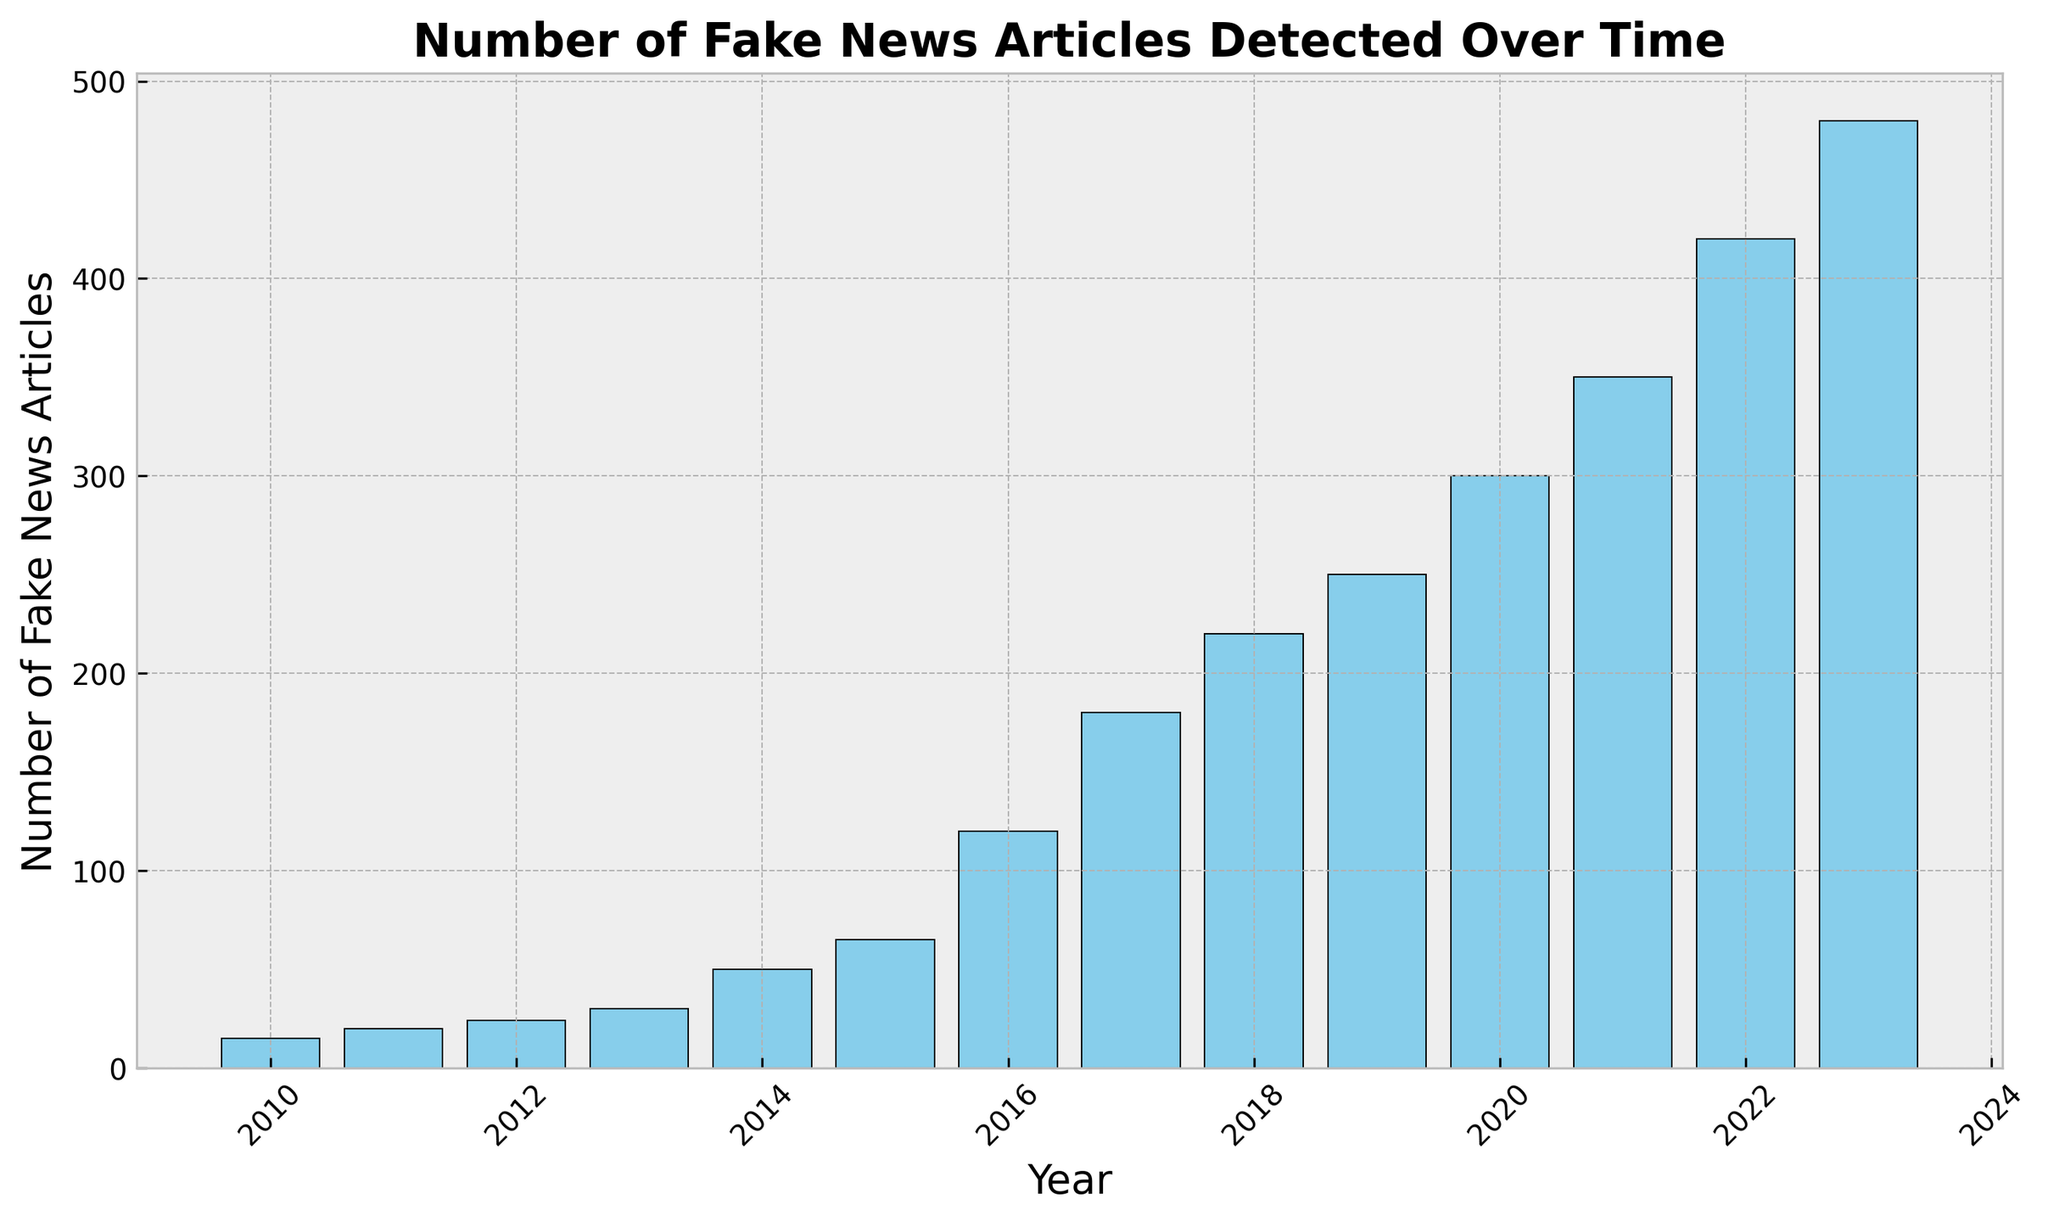What is the total number of fake news articles detected from 2010 to 2023? To find the total, sum all the values from the "NumberOfFakeNewsArticles" column: 15 + 20 + 24 + 30 + 50 + 65 + 120 + 180 + 220 + 250 + 300 + 350 + 420 + 480 = 2524
Answer: 2524 Which year saw the highest number of fake news articles detected? Simply find the tallest bar in the histogram. The year 2023 has the highest bar, representing the highest number of fake news articles at 480.
Answer: 2023 What is the increase in the number of fake news articles detected from 2013 to 2016? Subtract the number of fake news articles in 2013 from the number in 2016: 120 - 30 = 90
Answer: 90 How many years saw more than 200 fake news articles detected? Identify the bars with heights greater than 200. The years are 2018, 2019, 2020, 2021, 2022, and 2023. This totals to 6 years.
Answer: 6 What is the average number of fake news articles detected per year from 2010 to 2023? First, find the total number of fake news articles: 2524. Then divide by the number of years (14): 2524 / 14 ≈ 180.29
Answer: 180.29 By how much did the number of fake news articles increase from 2020 to 2021? Subtract the 2020 value from the 2021 value: 350 - 300 = 50
Answer: 50 Which year experienced the smallest increase in the number of fake news articles compared to the previous year? Calculate the yearly increases: (2011-2010) 5, (2012-2011) 4, (2013-2012) 6, (2014-2013) 20, (2015-2014) 15, (2016-2015) 55, (2017-2016) 60, (2018-2017) 40, (2019-2018) 30, (2020-2019) 50, (2021-2020) 50, (2022-2021) 70, (2023-2022) 60. The smallest increase is from 2012 to 2011 with an increase of 4 articles.
Answer: 2012 What is the median number of fake news articles detected from 2010 to 2023? First, list the numbers in ascending order: 15, 20, 24, 30, 50, 65, 120, 180, 220, 250, 300, 350, 420, 480. The median is the middle value: (120 + 180) / 2 = 150
Answer: 150 